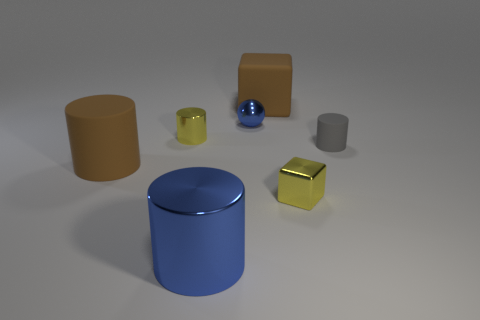Subtract all green cylinders. Subtract all red blocks. How many cylinders are left? 4 Add 2 big blue rubber cylinders. How many objects exist? 9 Subtract all cylinders. How many objects are left? 3 Add 3 tiny metallic things. How many tiny metallic things are left? 6 Add 4 red things. How many red things exist? 4 Subtract 0 cyan cubes. How many objects are left? 7 Subtract all large cyan metal blocks. Subtract all big brown rubber cylinders. How many objects are left? 6 